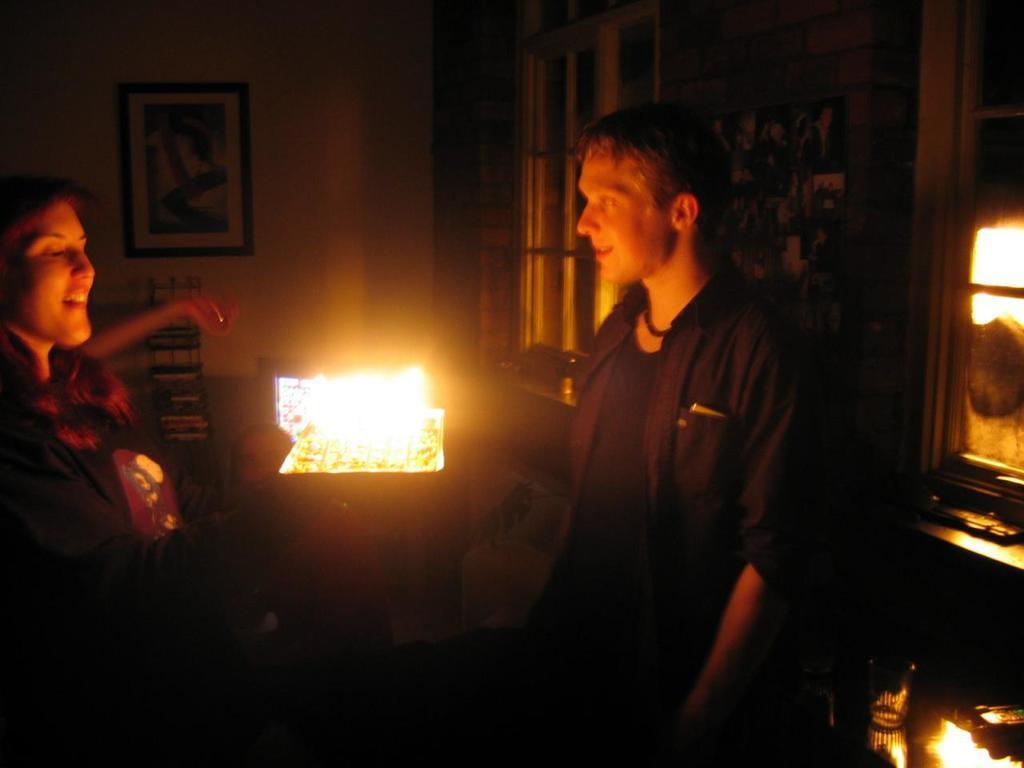How would you summarize this image in a sentence or two? This picture is taken in the dark. I can see two people, one man and a woman. I can see a light in the center of the image , a wall painting hanging on the wall, on the right hand side I can see a window and some other unclear objects in the image. 